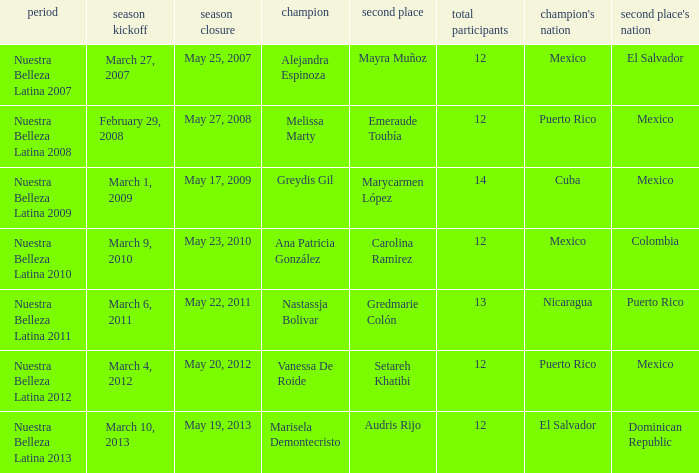What season's premiere had puerto rico winning on May 20, 2012? March 4, 2012. 